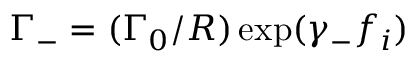Convert formula to latex. <formula><loc_0><loc_0><loc_500><loc_500>\Gamma _ { - } = ( \Gamma _ { 0 } / R ) \exp ( \gamma _ { - } f _ { i } )</formula> 